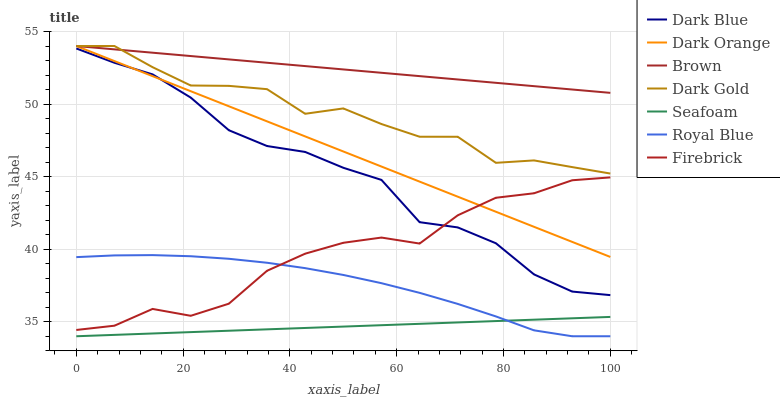Does Seafoam have the minimum area under the curve?
Answer yes or no. Yes. Does Brown have the maximum area under the curve?
Answer yes or no. Yes. Does Royal Blue have the minimum area under the curve?
Answer yes or no. No. Does Royal Blue have the maximum area under the curve?
Answer yes or no. No. Is Brown the smoothest?
Answer yes or no. Yes. Is Dark Gold the roughest?
Answer yes or no. Yes. Is Royal Blue the smoothest?
Answer yes or no. No. Is Royal Blue the roughest?
Answer yes or no. No. Does Royal Blue have the lowest value?
Answer yes or no. Yes. Does Dark Gold have the lowest value?
Answer yes or no. No. Does Dark Orange have the highest value?
Answer yes or no. Yes. Does Royal Blue have the highest value?
Answer yes or no. No. Is Dark Blue less than Dark Gold?
Answer yes or no. Yes. Is Brown greater than Seafoam?
Answer yes or no. Yes. Does Dark Orange intersect Firebrick?
Answer yes or no. Yes. Is Dark Orange less than Firebrick?
Answer yes or no. No. Is Dark Orange greater than Firebrick?
Answer yes or no. No. Does Dark Blue intersect Dark Gold?
Answer yes or no. No. 